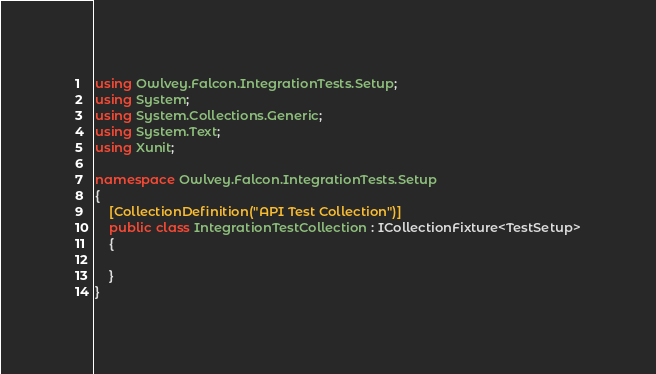<code> <loc_0><loc_0><loc_500><loc_500><_C#_>using Owlvey.Falcon.IntegrationTests.Setup;
using System;
using System.Collections.Generic;
using System.Text;
using Xunit;

namespace Owlvey.Falcon.IntegrationTests.Setup
{
    [CollectionDefinition("API Test Collection")]
    public class IntegrationTestCollection : ICollectionFixture<TestSetup>
    {

    }
}
</code> 